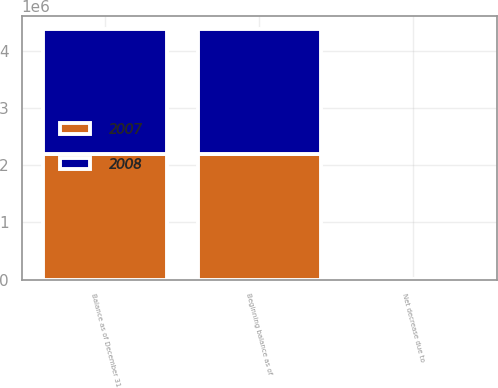<chart> <loc_0><loc_0><loc_500><loc_500><stacked_bar_chart><ecel><fcel>Beginning balance as of<fcel>Net decrease due to<fcel>Balance as of December 31<nl><fcel>2007<fcel>2.18831e+06<fcel>2079<fcel>2.18623e+06<nl><fcel>2008<fcel>2.18977e+06<fcel>1455<fcel>2.18831e+06<nl></chart> 